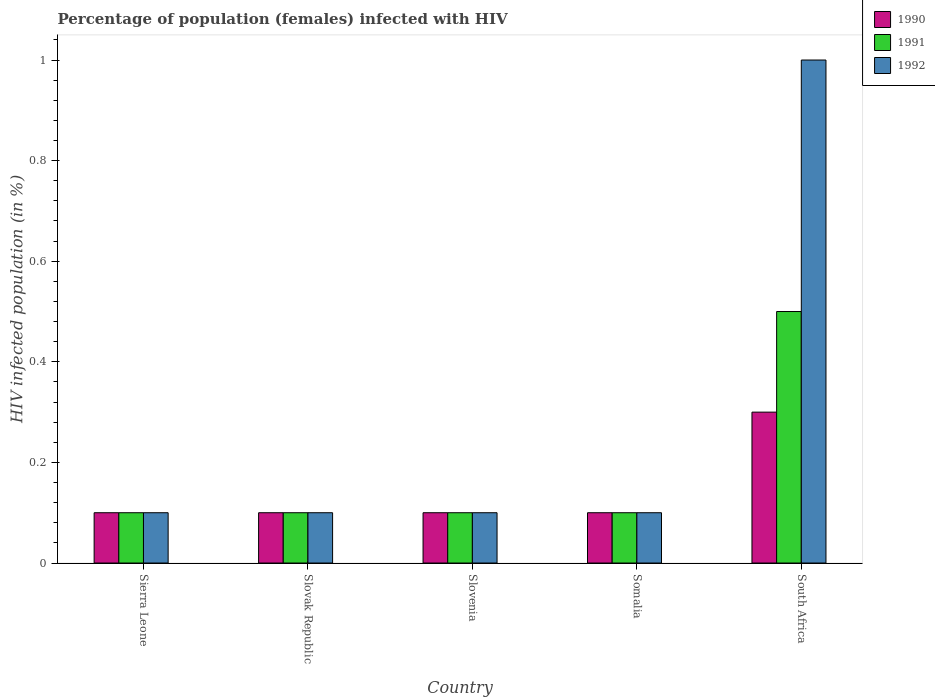How many groups of bars are there?
Your response must be concise. 5. Are the number of bars on each tick of the X-axis equal?
Your answer should be compact. Yes. How many bars are there on the 2nd tick from the left?
Provide a short and direct response. 3. What is the label of the 2nd group of bars from the left?
Ensure brevity in your answer.  Slovak Republic. In how many cases, is the number of bars for a given country not equal to the number of legend labels?
Offer a terse response. 0. What is the percentage of HIV infected female population in 1990 in Slovak Republic?
Your response must be concise. 0.1. Across all countries, what is the maximum percentage of HIV infected female population in 1991?
Offer a very short reply. 0.5. Across all countries, what is the minimum percentage of HIV infected female population in 1991?
Your response must be concise. 0.1. In which country was the percentage of HIV infected female population in 1991 maximum?
Provide a short and direct response. South Africa. In which country was the percentage of HIV infected female population in 1992 minimum?
Your answer should be very brief. Sierra Leone. What is the difference between the percentage of HIV infected female population in 1992 in Slovenia and that in Somalia?
Your answer should be very brief. 0. What is the difference between the percentage of HIV infected female population in 1990 in Slovak Republic and the percentage of HIV infected female population in 1991 in Somalia?
Make the answer very short. 0. What is the average percentage of HIV infected female population in 1990 per country?
Make the answer very short. 0.14. What is the ratio of the percentage of HIV infected female population in 1990 in Sierra Leone to that in Slovak Republic?
Give a very brief answer. 1. Is the difference between the percentage of HIV infected female population in 1991 in Somalia and South Africa greater than the difference between the percentage of HIV infected female population in 1992 in Somalia and South Africa?
Ensure brevity in your answer.  Yes. What is the difference between the highest and the lowest percentage of HIV infected female population in 1992?
Your answer should be very brief. 0.9. In how many countries, is the percentage of HIV infected female population in 1990 greater than the average percentage of HIV infected female population in 1990 taken over all countries?
Offer a very short reply. 1. Is the sum of the percentage of HIV infected female population in 1991 in Somalia and South Africa greater than the maximum percentage of HIV infected female population in 1992 across all countries?
Provide a short and direct response. No. What does the 2nd bar from the right in Sierra Leone represents?
Offer a very short reply. 1991. How many bars are there?
Ensure brevity in your answer.  15. Are all the bars in the graph horizontal?
Offer a very short reply. No. How many countries are there in the graph?
Your response must be concise. 5. Are the values on the major ticks of Y-axis written in scientific E-notation?
Your answer should be very brief. No. Does the graph contain any zero values?
Provide a short and direct response. No. Does the graph contain grids?
Your answer should be very brief. No. Where does the legend appear in the graph?
Offer a very short reply. Top right. How are the legend labels stacked?
Provide a short and direct response. Vertical. What is the title of the graph?
Provide a short and direct response. Percentage of population (females) infected with HIV. What is the label or title of the X-axis?
Offer a very short reply. Country. What is the label or title of the Y-axis?
Your answer should be very brief. HIV infected population (in %). What is the HIV infected population (in %) in 1992 in Sierra Leone?
Your answer should be compact. 0.1. What is the HIV infected population (in %) of 1990 in Slovak Republic?
Provide a short and direct response. 0.1. What is the HIV infected population (in %) of 1991 in Slovak Republic?
Your answer should be compact. 0.1. What is the HIV infected population (in %) of 1991 in South Africa?
Your answer should be compact. 0.5. Across all countries, what is the maximum HIV infected population (in %) in 1990?
Provide a succinct answer. 0.3. Across all countries, what is the minimum HIV infected population (in %) in 1990?
Your response must be concise. 0.1. What is the total HIV infected population (in %) of 1990 in the graph?
Give a very brief answer. 0.7. What is the total HIV infected population (in %) in 1991 in the graph?
Make the answer very short. 0.9. What is the total HIV infected population (in %) of 1992 in the graph?
Provide a succinct answer. 1.4. What is the difference between the HIV infected population (in %) in 1990 in Sierra Leone and that in Slovak Republic?
Your answer should be compact. 0. What is the difference between the HIV infected population (in %) in 1992 in Sierra Leone and that in Slovak Republic?
Keep it short and to the point. 0. What is the difference between the HIV infected population (in %) in 1990 in Sierra Leone and that in Slovenia?
Make the answer very short. 0. What is the difference between the HIV infected population (in %) in 1991 in Sierra Leone and that in Slovenia?
Make the answer very short. 0. What is the difference between the HIV infected population (in %) of 1992 in Sierra Leone and that in Slovenia?
Provide a succinct answer. 0. What is the difference between the HIV infected population (in %) of 1991 in Sierra Leone and that in Somalia?
Offer a terse response. 0. What is the difference between the HIV infected population (in %) in 1990 in Sierra Leone and that in South Africa?
Ensure brevity in your answer.  -0.2. What is the difference between the HIV infected population (in %) in 1992 in Sierra Leone and that in South Africa?
Ensure brevity in your answer.  -0.9. What is the difference between the HIV infected population (in %) of 1990 in Slovak Republic and that in Slovenia?
Your answer should be very brief. 0. What is the difference between the HIV infected population (in %) in 1992 in Slovak Republic and that in Slovenia?
Offer a terse response. 0. What is the difference between the HIV infected population (in %) of 1990 in Slovak Republic and that in South Africa?
Your response must be concise. -0.2. What is the difference between the HIV infected population (in %) of 1992 in Slovak Republic and that in South Africa?
Keep it short and to the point. -0.9. What is the difference between the HIV infected population (in %) in 1990 in Slovenia and that in Somalia?
Give a very brief answer. 0. What is the difference between the HIV infected population (in %) in 1991 in Slovenia and that in South Africa?
Your response must be concise. -0.4. What is the difference between the HIV infected population (in %) of 1990 in Somalia and that in South Africa?
Keep it short and to the point. -0.2. What is the difference between the HIV infected population (in %) of 1991 in Somalia and that in South Africa?
Make the answer very short. -0.4. What is the difference between the HIV infected population (in %) in 1992 in Somalia and that in South Africa?
Offer a terse response. -0.9. What is the difference between the HIV infected population (in %) of 1991 in Sierra Leone and the HIV infected population (in %) of 1992 in Slovak Republic?
Provide a succinct answer. 0. What is the difference between the HIV infected population (in %) in 1991 in Sierra Leone and the HIV infected population (in %) in 1992 in Slovenia?
Provide a succinct answer. 0. What is the difference between the HIV infected population (in %) of 1990 in Sierra Leone and the HIV infected population (in %) of 1991 in Somalia?
Make the answer very short. 0. What is the difference between the HIV infected population (in %) in 1990 in Sierra Leone and the HIV infected population (in %) in 1992 in Somalia?
Make the answer very short. 0. What is the difference between the HIV infected population (in %) in 1991 in Sierra Leone and the HIV infected population (in %) in 1992 in Somalia?
Offer a very short reply. 0. What is the difference between the HIV infected population (in %) in 1990 in Slovak Republic and the HIV infected population (in %) in 1991 in Slovenia?
Offer a very short reply. 0. What is the difference between the HIV infected population (in %) in 1990 in Slovak Republic and the HIV infected population (in %) in 1992 in Slovenia?
Provide a short and direct response. 0. What is the difference between the HIV infected population (in %) of 1990 in Slovak Republic and the HIV infected population (in %) of 1991 in Somalia?
Provide a short and direct response. 0. What is the difference between the HIV infected population (in %) in 1991 in Slovak Republic and the HIV infected population (in %) in 1992 in Somalia?
Your response must be concise. 0. What is the difference between the HIV infected population (in %) in 1991 in Slovak Republic and the HIV infected population (in %) in 1992 in South Africa?
Ensure brevity in your answer.  -0.9. What is the difference between the HIV infected population (in %) of 1990 in Slovenia and the HIV infected population (in %) of 1991 in South Africa?
Offer a very short reply. -0.4. What is the difference between the HIV infected population (in %) of 1990 in Slovenia and the HIV infected population (in %) of 1992 in South Africa?
Offer a very short reply. -0.9. What is the difference between the HIV infected population (in %) in 1991 in Slovenia and the HIV infected population (in %) in 1992 in South Africa?
Your answer should be compact. -0.9. What is the difference between the HIV infected population (in %) in 1990 in Somalia and the HIV infected population (in %) in 1991 in South Africa?
Give a very brief answer. -0.4. What is the average HIV infected population (in %) of 1990 per country?
Give a very brief answer. 0.14. What is the average HIV infected population (in %) of 1991 per country?
Make the answer very short. 0.18. What is the average HIV infected population (in %) in 1992 per country?
Make the answer very short. 0.28. What is the difference between the HIV infected population (in %) of 1990 and HIV infected population (in %) of 1991 in Sierra Leone?
Your response must be concise. 0. What is the difference between the HIV infected population (in %) of 1991 and HIV infected population (in %) of 1992 in Sierra Leone?
Offer a very short reply. 0. What is the difference between the HIV infected population (in %) in 1990 and HIV infected population (in %) in 1991 in Slovak Republic?
Offer a very short reply. 0. What is the difference between the HIV infected population (in %) in 1991 and HIV infected population (in %) in 1992 in Slovak Republic?
Give a very brief answer. 0. What is the difference between the HIV infected population (in %) in 1990 and HIV infected population (in %) in 1991 in Slovenia?
Provide a short and direct response. 0. What is the difference between the HIV infected population (in %) of 1990 and HIV infected population (in %) of 1992 in Slovenia?
Provide a succinct answer. 0. What is the difference between the HIV infected population (in %) of 1990 and HIV infected population (in %) of 1992 in Somalia?
Give a very brief answer. 0. What is the difference between the HIV infected population (in %) in 1991 and HIV infected population (in %) in 1992 in Somalia?
Ensure brevity in your answer.  0. What is the difference between the HIV infected population (in %) in 1991 and HIV infected population (in %) in 1992 in South Africa?
Make the answer very short. -0.5. What is the ratio of the HIV infected population (in %) in 1990 in Sierra Leone to that in Slovak Republic?
Offer a terse response. 1. What is the ratio of the HIV infected population (in %) in 1991 in Sierra Leone to that in Slovak Republic?
Provide a short and direct response. 1. What is the ratio of the HIV infected population (in %) in 1992 in Sierra Leone to that in Slovak Republic?
Ensure brevity in your answer.  1. What is the ratio of the HIV infected population (in %) in 1990 in Sierra Leone to that in Slovenia?
Give a very brief answer. 1. What is the ratio of the HIV infected population (in %) of 1990 in Sierra Leone to that in South Africa?
Your answer should be very brief. 0.33. What is the ratio of the HIV infected population (in %) in 1991 in Sierra Leone to that in South Africa?
Offer a very short reply. 0.2. What is the ratio of the HIV infected population (in %) in 1990 in Slovak Republic to that in Slovenia?
Offer a terse response. 1. What is the ratio of the HIV infected population (in %) of 1991 in Slovak Republic to that in Slovenia?
Your answer should be very brief. 1. What is the ratio of the HIV infected population (in %) of 1992 in Slovak Republic to that in Slovenia?
Offer a terse response. 1. What is the ratio of the HIV infected population (in %) of 1992 in Slovak Republic to that in Somalia?
Your answer should be very brief. 1. What is the ratio of the HIV infected population (in %) of 1990 in Slovak Republic to that in South Africa?
Offer a very short reply. 0.33. What is the ratio of the HIV infected population (in %) of 1992 in Slovak Republic to that in South Africa?
Provide a succinct answer. 0.1. What is the ratio of the HIV infected population (in %) of 1990 in Slovenia to that in Somalia?
Keep it short and to the point. 1. What is the ratio of the HIV infected population (in %) of 1991 in Slovenia to that in Somalia?
Make the answer very short. 1. What is the ratio of the HIV infected population (in %) in 1992 in Slovenia to that in Somalia?
Make the answer very short. 1. What is the ratio of the HIV infected population (in %) of 1990 in Slovenia to that in South Africa?
Your answer should be very brief. 0.33. What is the ratio of the HIV infected population (in %) in 1991 in Slovenia to that in South Africa?
Your answer should be compact. 0.2. What is the ratio of the HIV infected population (in %) in 1992 in Slovenia to that in South Africa?
Provide a succinct answer. 0.1. What is the ratio of the HIV infected population (in %) of 1990 in Somalia to that in South Africa?
Give a very brief answer. 0.33. What is the difference between the highest and the second highest HIV infected population (in %) in 1991?
Make the answer very short. 0.4. What is the difference between the highest and the lowest HIV infected population (in %) in 1991?
Offer a very short reply. 0.4. What is the difference between the highest and the lowest HIV infected population (in %) in 1992?
Keep it short and to the point. 0.9. 